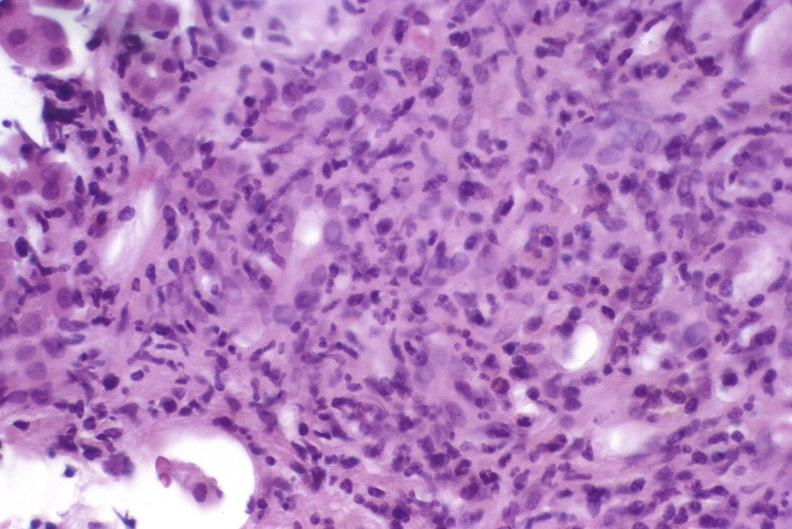what does this image show?
Answer the question using a single word or phrase. Autoimmune hepatitis 